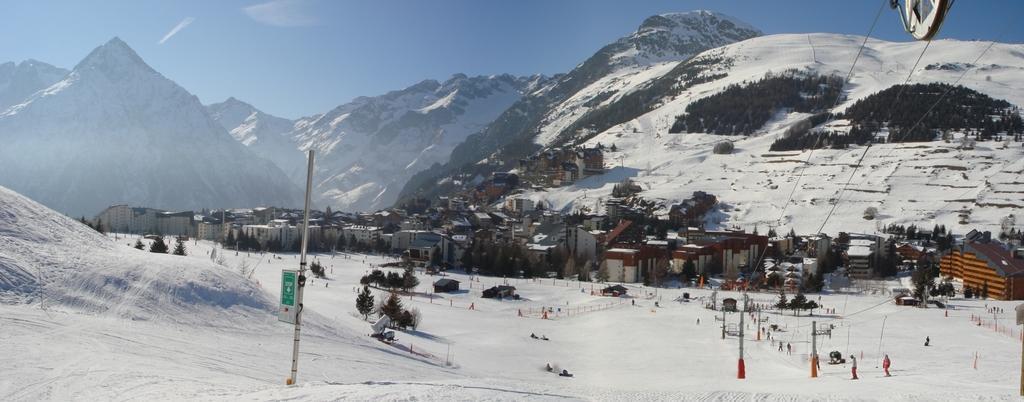In one or two sentences, can you explain what this image depicts? In the image we can see the ground is covered with snow and people standing on the ground. There are lot of trees and there are buildings. Behind there are mountains which are covered with snow and there are wires attached to the pole. 